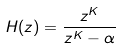<formula> <loc_0><loc_0><loc_500><loc_500>H ( z ) = \frac { z ^ { K } } { z ^ { K } - \alpha }</formula> 